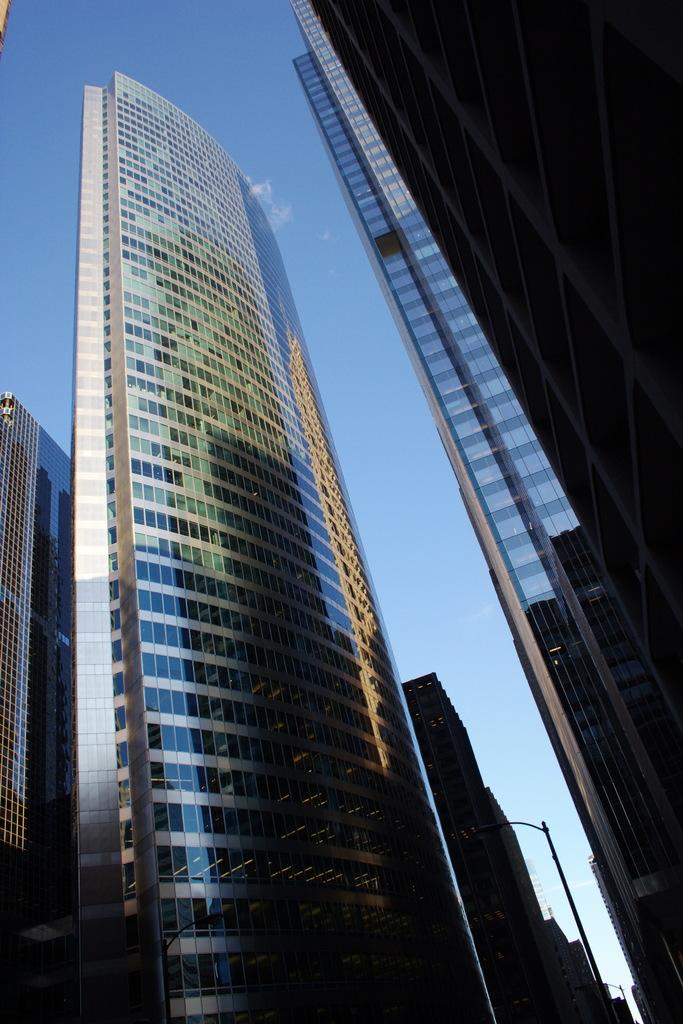What type of structures can be seen in the image? There are buildings in the image. What else can be seen in the image besides the buildings? There are light poles in the image. What color is the sky in the image? The sky is blue in the image. Where is the library located in the image? There is no library mentioned or visible in the image. Can you see a zebra in the image? No, there is no zebra present in the image. 